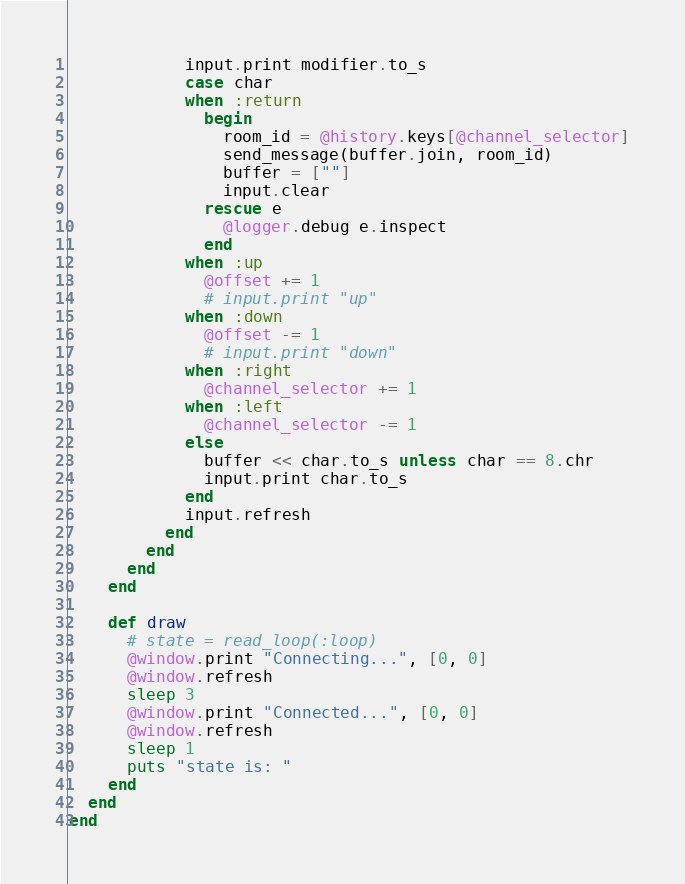Convert code to text. <code><loc_0><loc_0><loc_500><loc_500><_Crystal_>            input.print modifier.to_s
            case char
            when :return
              begin
                room_id = @history.keys[@channel_selector]
                send_message(buffer.join, room_id)
                buffer = [""]
                input.clear
              rescue e
                @logger.debug e.inspect
              end
            when :up
              @offset += 1
              # input.print "up"
            when :down
              @offset -= 1
              # input.print "down"
            when :right
              @channel_selector += 1
            when :left
              @channel_selector -= 1
            else
              buffer << char.to_s unless char == 8.chr
              input.print char.to_s
            end
            input.refresh
          end
        end
      end
    end

    def draw
      # state = read_loop(:loop)
      @window.print "Connecting...", [0, 0]
      @window.refresh
      sleep 3
      @window.print "Connected...", [0, 0]
      @window.refresh
      sleep 1
      puts "state is: "
    end
  end
end
</code> 